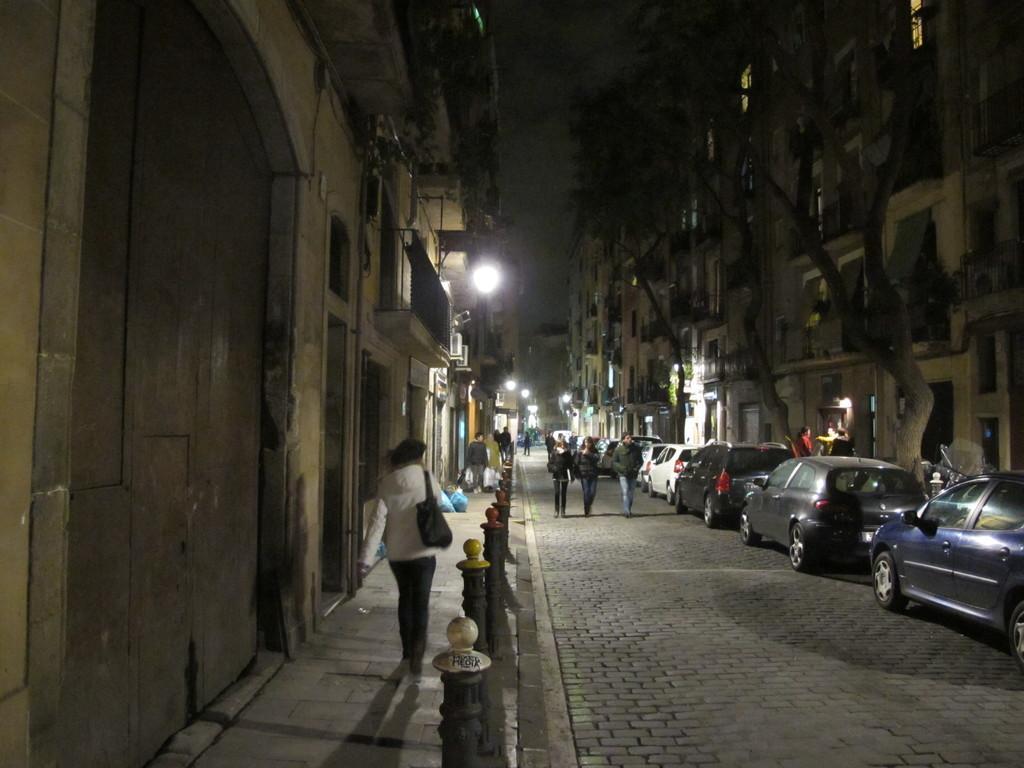How would you summarize this image in a sentence or two? In this picture there is a woman who is wearing white jacket, black trouser, shoe and bag. She is walking on the street. Beside her I can see the doors and windows. In the center I can see the group of persons were walking on the road. Beside them I can see many cars which are parked near to the trees. In the background I can see the lights, street lights, buildings, fencing, railing and other objects. At the top I can see the sky. 